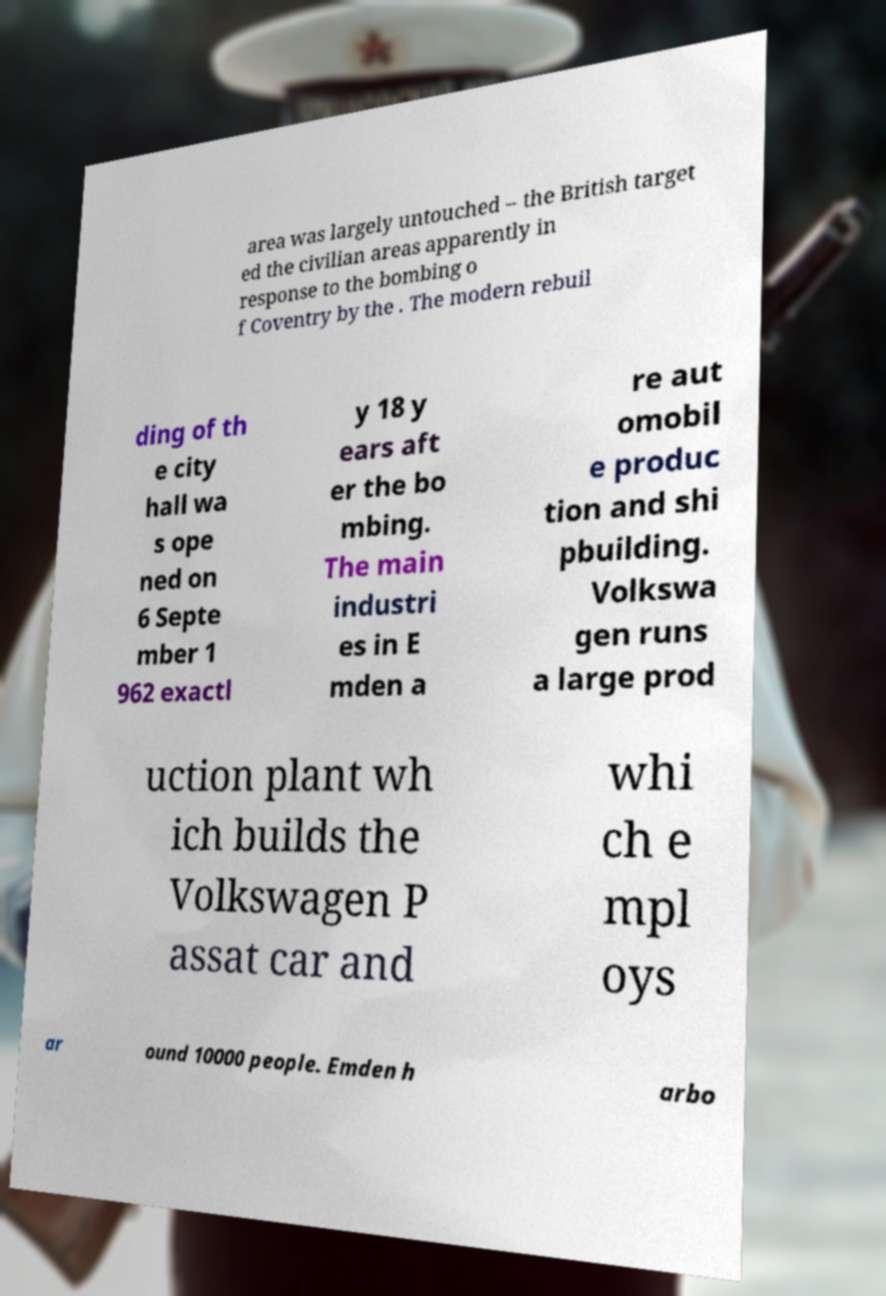Please identify and transcribe the text found in this image. area was largely untouched – the British target ed the civilian areas apparently in response to the bombing o f Coventry by the . The modern rebuil ding of th e city hall wa s ope ned on 6 Septe mber 1 962 exactl y 18 y ears aft er the bo mbing. The main industri es in E mden a re aut omobil e produc tion and shi pbuilding. Volkswa gen runs a large prod uction plant wh ich builds the Volkswagen P assat car and whi ch e mpl oys ar ound 10000 people. Emden h arbo 